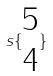<formula> <loc_0><loc_0><loc_500><loc_500>s \{ \begin{matrix} 5 \\ 4 \end{matrix} \}</formula> 